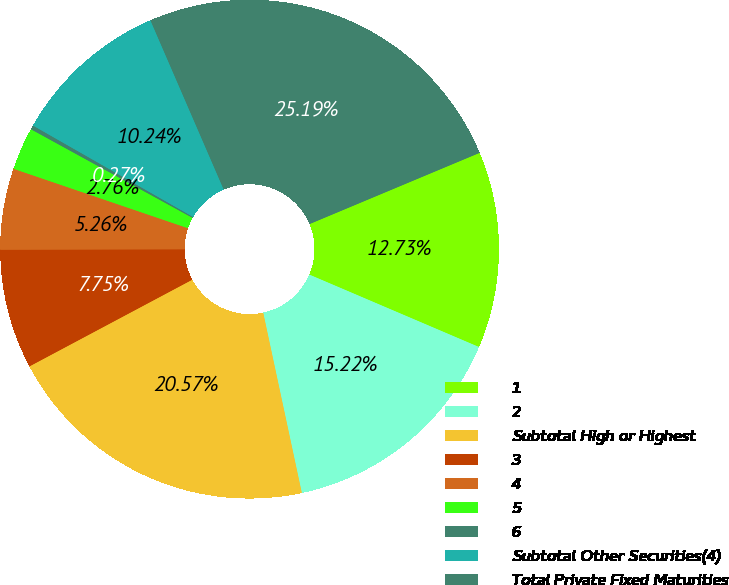<chart> <loc_0><loc_0><loc_500><loc_500><pie_chart><fcel>1<fcel>2<fcel>Subtotal High or Highest<fcel>3<fcel>4<fcel>5<fcel>6<fcel>Subtotal Other Securities(4)<fcel>Total Private Fixed Maturities<nl><fcel>12.73%<fcel>15.22%<fcel>20.57%<fcel>7.75%<fcel>5.26%<fcel>2.76%<fcel>0.27%<fcel>10.24%<fcel>25.19%<nl></chart> 